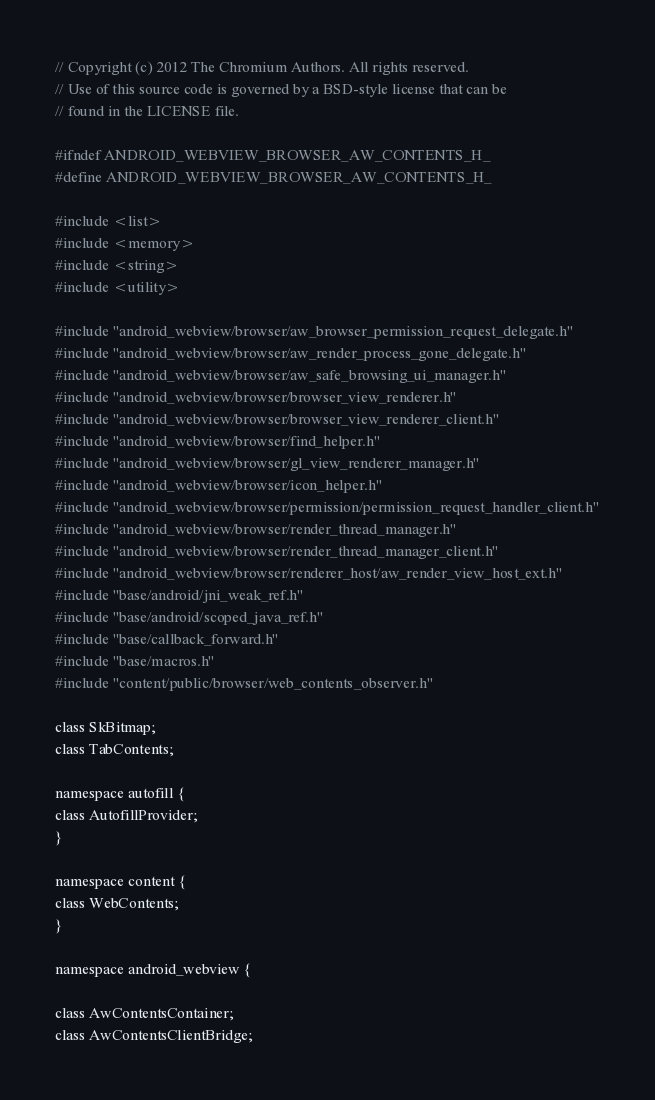<code> <loc_0><loc_0><loc_500><loc_500><_C_>// Copyright (c) 2012 The Chromium Authors. All rights reserved.
// Use of this source code is governed by a BSD-style license that can be
// found in the LICENSE file.

#ifndef ANDROID_WEBVIEW_BROWSER_AW_CONTENTS_H_
#define ANDROID_WEBVIEW_BROWSER_AW_CONTENTS_H_

#include <list>
#include <memory>
#include <string>
#include <utility>

#include "android_webview/browser/aw_browser_permission_request_delegate.h"
#include "android_webview/browser/aw_render_process_gone_delegate.h"
#include "android_webview/browser/aw_safe_browsing_ui_manager.h"
#include "android_webview/browser/browser_view_renderer.h"
#include "android_webview/browser/browser_view_renderer_client.h"
#include "android_webview/browser/find_helper.h"
#include "android_webview/browser/gl_view_renderer_manager.h"
#include "android_webview/browser/icon_helper.h"
#include "android_webview/browser/permission/permission_request_handler_client.h"
#include "android_webview/browser/render_thread_manager.h"
#include "android_webview/browser/render_thread_manager_client.h"
#include "android_webview/browser/renderer_host/aw_render_view_host_ext.h"
#include "base/android/jni_weak_ref.h"
#include "base/android/scoped_java_ref.h"
#include "base/callback_forward.h"
#include "base/macros.h"
#include "content/public/browser/web_contents_observer.h"

class SkBitmap;
class TabContents;

namespace autofill {
class AutofillProvider;
}

namespace content {
class WebContents;
}

namespace android_webview {

class AwContentsContainer;
class AwContentsClientBridge;</code> 